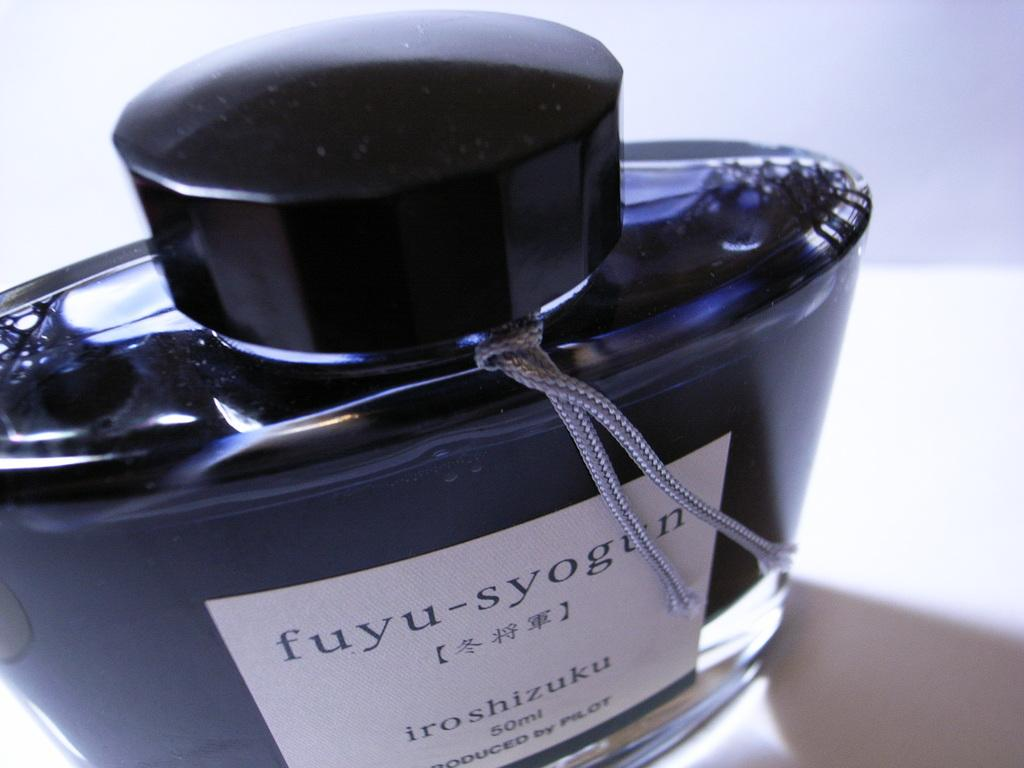Provide a one-sentence caption for the provided image. Fuyu syogun iroshizuku fifty ml cologne produced by pilot. 